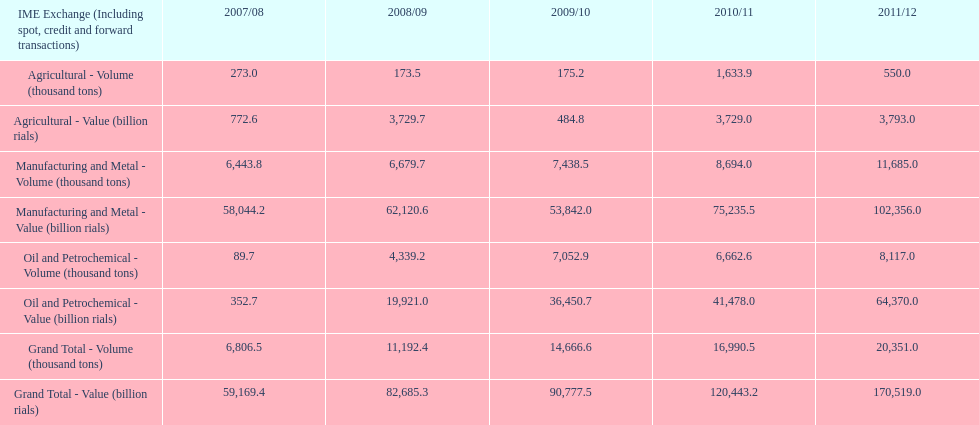Over how many years was iran's agricultural value more than 500 billion rials? 4. 